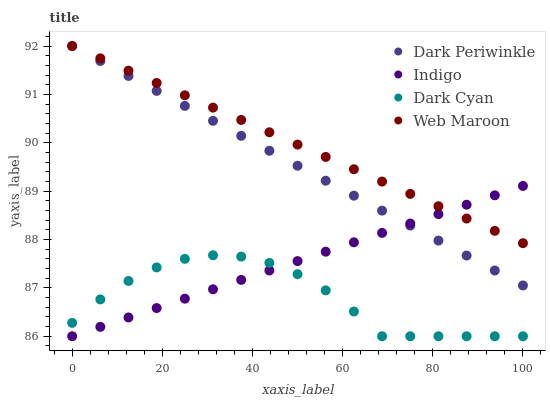Does Dark Cyan have the minimum area under the curve?
Answer yes or no. Yes. Does Web Maroon have the maximum area under the curve?
Answer yes or no. Yes. Does Indigo have the minimum area under the curve?
Answer yes or no. No. Does Indigo have the maximum area under the curve?
Answer yes or no. No. Is Indigo the smoothest?
Answer yes or no. Yes. Is Dark Cyan the roughest?
Answer yes or no. Yes. Is Web Maroon the smoothest?
Answer yes or no. No. Is Web Maroon the roughest?
Answer yes or no. No. Does Dark Cyan have the lowest value?
Answer yes or no. Yes. Does Web Maroon have the lowest value?
Answer yes or no. No. Does Dark Periwinkle have the highest value?
Answer yes or no. Yes. Does Indigo have the highest value?
Answer yes or no. No. Is Dark Cyan less than Web Maroon?
Answer yes or no. Yes. Is Dark Periwinkle greater than Dark Cyan?
Answer yes or no. Yes. Does Dark Periwinkle intersect Web Maroon?
Answer yes or no. Yes. Is Dark Periwinkle less than Web Maroon?
Answer yes or no. No. Is Dark Periwinkle greater than Web Maroon?
Answer yes or no. No. Does Dark Cyan intersect Web Maroon?
Answer yes or no. No. 